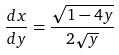<formula> <loc_0><loc_0><loc_500><loc_500>\frac { d x } { d y } = \frac { \sqrt { 1 - 4 y } } { 2 \sqrt { y } }</formula> 